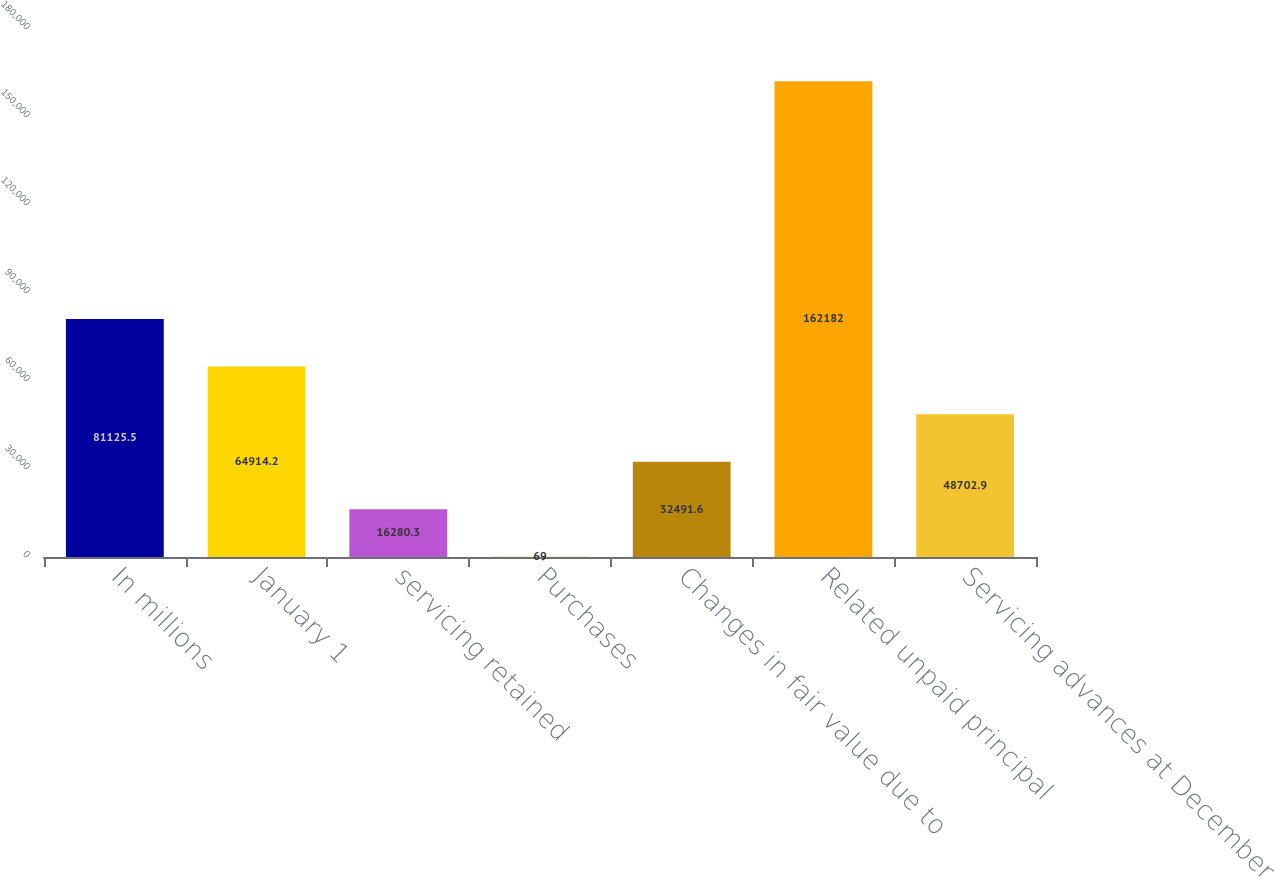Convert chart to OTSL. <chart><loc_0><loc_0><loc_500><loc_500><bar_chart><fcel>In millions<fcel>January 1<fcel>servicing retained<fcel>Purchases<fcel>Changes in fair value due to<fcel>Related unpaid principal<fcel>Servicing advances at December<nl><fcel>81125.5<fcel>64914.2<fcel>16280.3<fcel>69<fcel>32491.6<fcel>162182<fcel>48702.9<nl></chart> 